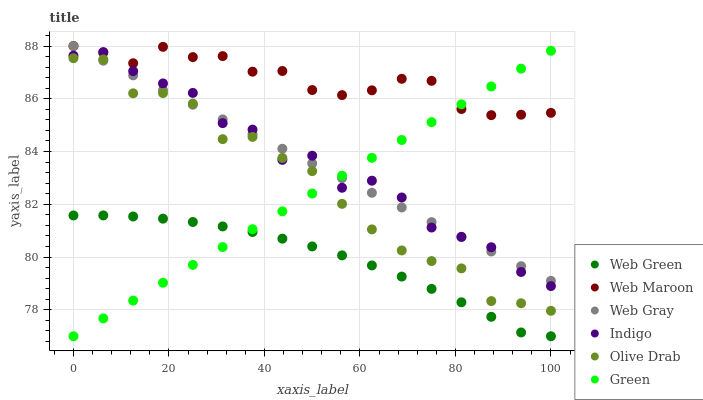Does Web Green have the minimum area under the curve?
Answer yes or no. Yes. Does Web Maroon have the maximum area under the curve?
Answer yes or no. Yes. Does Indigo have the minimum area under the curve?
Answer yes or no. No. Does Indigo have the maximum area under the curve?
Answer yes or no. No. Is Green the smoothest?
Answer yes or no. Yes. Is Indigo the roughest?
Answer yes or no. Yes. Is Web Maroon the smoothest?
Answer yes or no. No. Is Web Maroon the roughest?
Answer yes or no. No. Does Web Green have the lowest value?
Answer yes or no. Yes. Does Indigo have the lowest value?
Answer yes or no. No. Does Web Maroon have the highest value?
Answer yes or no. Yes. Does Indigo have the highest value?
Answer yes or no. No. Is Olive Drab less than Web Maroon?
Answer yes or no. Yes. Is Web Maroon greater than Web Green?
Answer yes or no. Yes. Does Green intersect Olive Drab?
Answer yes or no. Yes. Is Green less than Olive Drab?
Answer yes or no. No. Is Green greater than Olive Drab?
Answer yes or no. No. Does Olive Drab intersect Web Maroon?
Answer yes or no. No. 